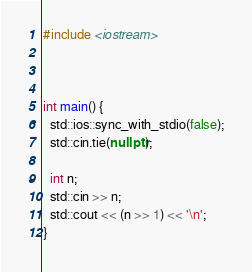Convert code to text. <code><loc_0><loc_0><loc_500><loc_500><_C++_>#include <iostream>



int main() {
  std::ios::sync_with_stdio(false);
  std::cin.tie(nullptr);

  int n;
  std::cin >> n;
  std::cout << (n >> 1) << '\n';
}</code> 